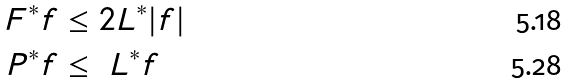Convert formula to latex. <formula><loc_0><loc_0><loc_500><loc_500>F ^ { * } f & \leq 2 L ^ { * } | f | \\ P ^ { * } f & \leq \ L ^ { * } f</formula> 